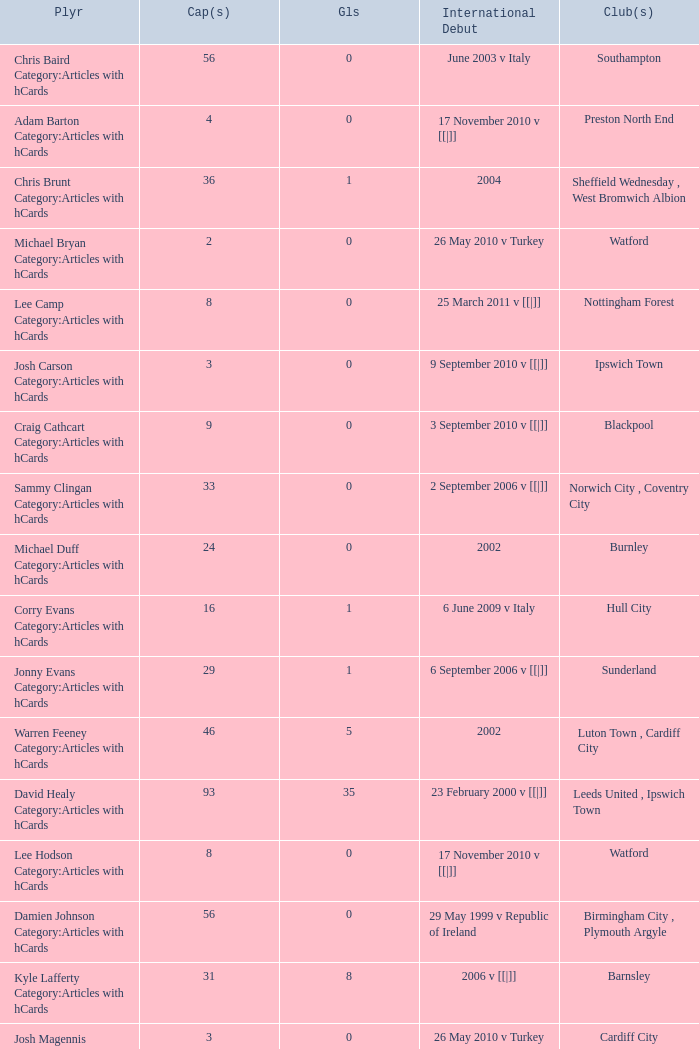How many caps figures for the Doncaster Rovers? 1.0. 